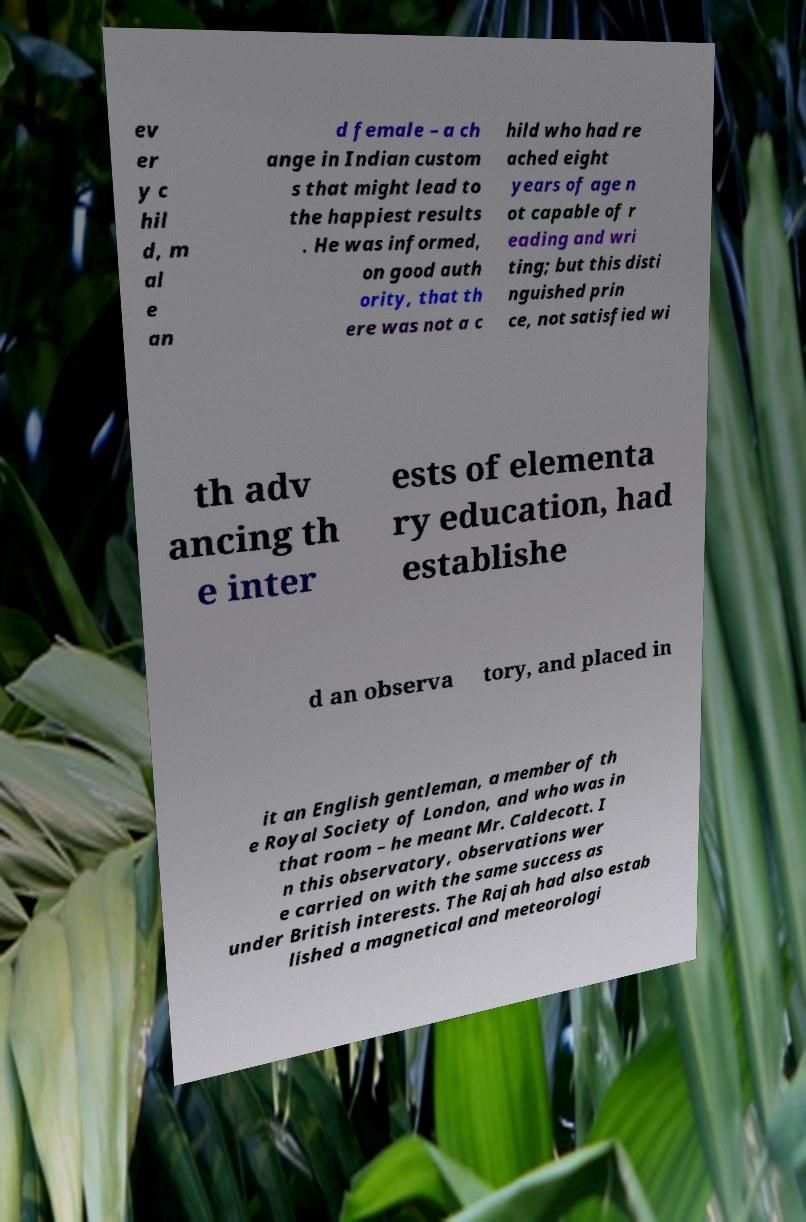Can you read and provide the text displayed in the image?This photo seems to have some interesting text. Can you extract and type it out for me? ev er y c hil d, m al e an d female – a ch ange in Indian custom s that might lead to the happiest results . He was informed, on good auth ority, that th ere was not a c hild who had re ached eight years of age n ot capable of r eading and wri ting; but this disti nguished prin ce, not satisfied wi th adv ancing th e inter ests of elementa ry education, had establishe d an observa tory, and placed in it an English gentleman, a member of th e Royal Society of London, and who was in that room – he meant Mr. Caldecott. I n this observatory, observations wer e carried on with the same success as under British interests. The Rajah had also estab lished a magnetical and meteorologi 